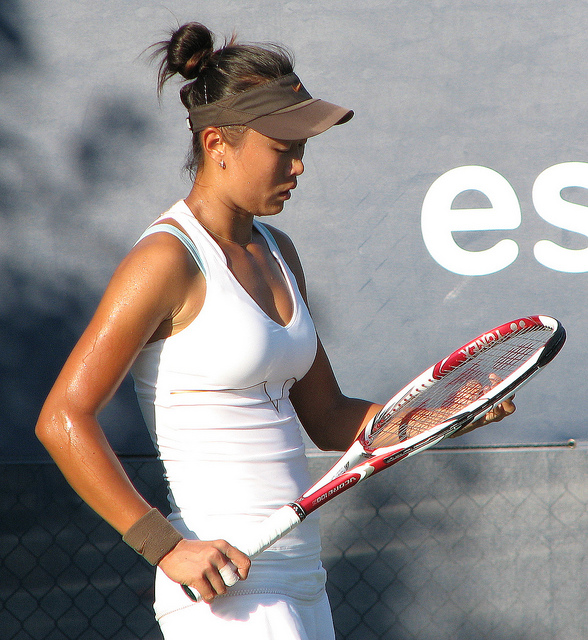<image>How tired is she? It is ambiguous to determine how tired she is. It may range from 'little' to 'very'. How tired is she? She looks very tired. 